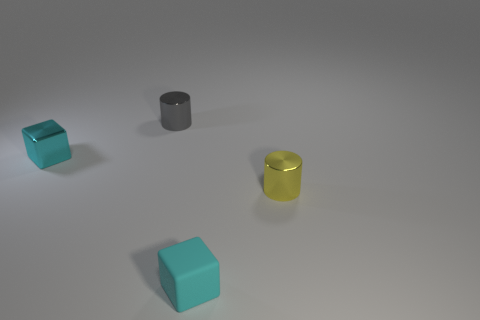What number of other matte cubes are the same color as the tiny matte block?
Your response must be concise. 0. What size is the shiny cylinder to the right of the small cube in front of the block that is left of the tiny gray cylinder?
Give a very brief answer. Small. How many tiny cyan objects are in front of the yellow thing?
Ensure brevity in your answer.  1. There is a small cylinder that is behind the small cyan thing behind the small yellow thing; what is its material?
Your answer should be compact. Metal. Do the yellow thing and the gray cylinder have the same size?
Ensure brevity in your answer.  Yes. How many things are either small objects that are on the left side of the tiny yellow cylinder or metal cylinders in front of the tiny metallic block?
Ensure brevity in your answer.  4. Are there more cyan cubes behind the cyan metal block than large red cylinders?
Give a very brief answer. No. What number of other objects are the same shape as the cyan metallic object?
Your response must be concise. 1. The small thing that is both right of the small gray metallic object and on the left side of the yellow object is made of what material?
Ensure brevity in your answer.  Rubber. What number of objects are large purple matte cylinders or cyan rubber blocks?
Provide a short and direct response. 1. 